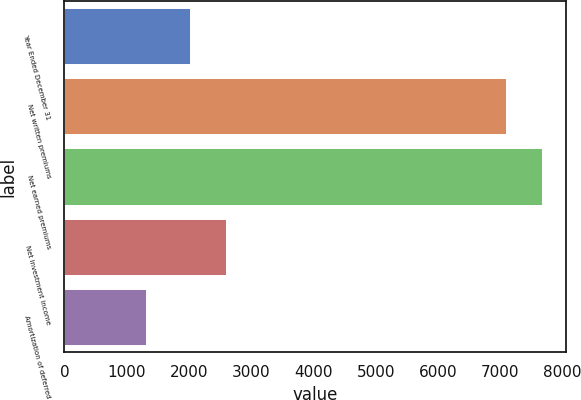<chart> <loc_0><loc_0><loc_500><loc_500><bar_chart><fcel>Year Ended December 31<fcel>Net written premiums<fcel>Net earned premiums<fcel>Net investment income<fcel>Amortization of deferred<nl><fcel>2014<fcel>7088<fcel>7677.5<fcel>2603.5<fcel>1317<nl></chart> 